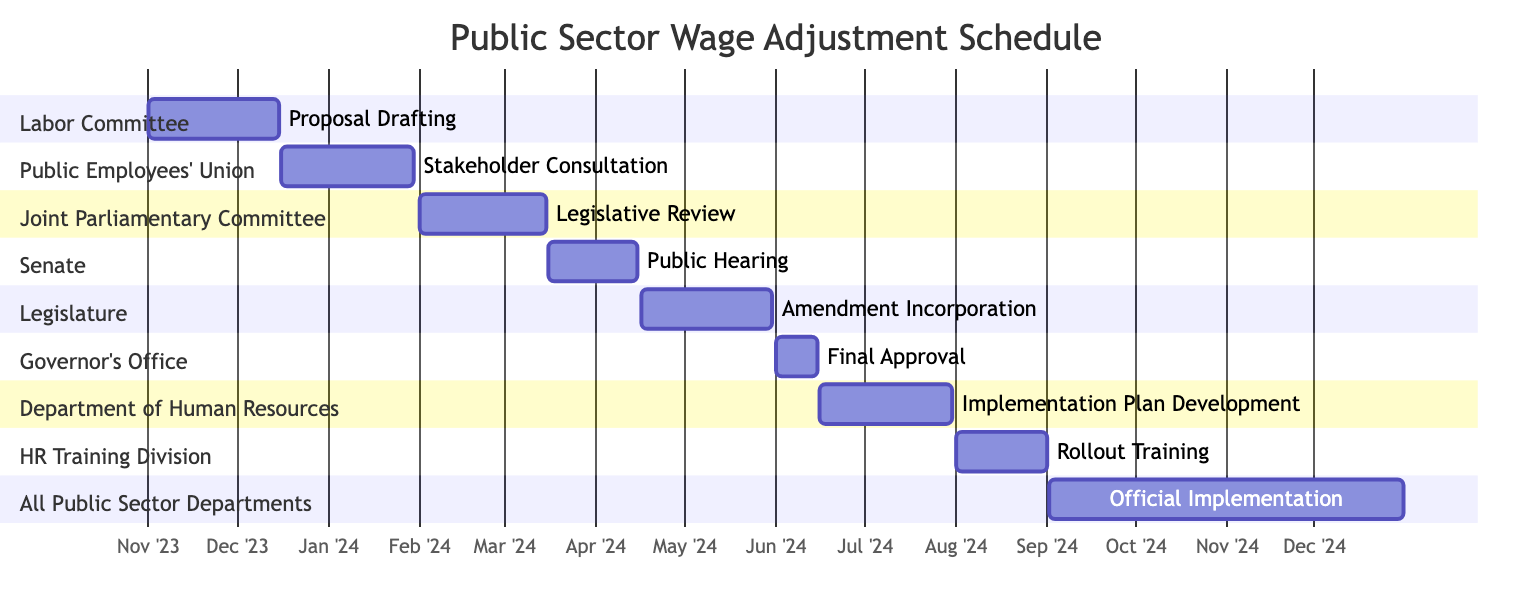What is the start date of the Proposal Drafting task? The Proposal Drafting task is indicated to start on November 1, 2023, in the Gantt chart.
Answer: November 1, 2023 How many tasks are scheduled in total? Counting all the tasks listed in the Gantt chart, there are a total of 9 distinct tasks outlined in the schedule.
Answer: 9 What does the final task in the schedule represent? The final task, which is "Official Implementation," signifies the execution of the proposed wage adjustments across all public sector departments from September 2, 2024, to December 31, 2024.
Answer: Official Implementation Which section is responsible for the Stakeholder Consultation task? The Stakeholder Consultation task is under the section dedicated to the Public Employees' Union, which directly indicates its ownership.
Answer: Public Employees' Union What is the duration of the Legislative Review task? The Legislative Review task spans from February 1, 2024, to March 15, 2024, which is a total of 43 days when calculated.
Answer: 43 days Which task begins immediately after the Public Hearing? After the Public Hearing, which concludes on April 15, 2024, the next task is Amendment Incorporation, starting on April 16, 2024.
Answer: Amendment Incorporation How long does the Implementation Plan Development phase last? The Implementation Plan Development phase starts on June 16, 2024, and ends on July 31, 2024, resulting in a duration of 45 days.
Answer: 45 days What does the task "Final Approval" signify in this schedule? The task "Final Approval," marked for June 1 to June 15, 2024, indicates the last step before full implementation, where the Governor's Office will finalize the approval of the wage adjustments.
Answer: Final Approval Which entity is responsible for Rollout Training? The entity in charge of the Rollout Training is the HR Training Division, as per the assignment shown in the Gantt chart.
Answer: HR Training Division 